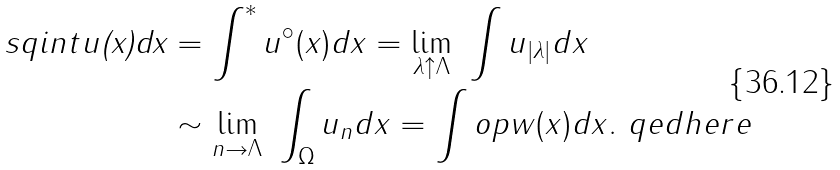Convert formula to latex. <formula><loc_0><loc_0><loc_500><loc_500>\ s q i n t u \text {\emph{(x)dx}} & = \int ^ { * } u ^ { \circ } ( x ) d x = \lim _ { \lambda \uparrow \Lambda } \ \int u _ { | \lambda | } d x \\ & \sim \lim _ { n \rightarrow \Lambda } \ \int _ { \Omega } u _ { n } d x = \int o p w ( x ) d x . \ q e d h e r e</formula> 